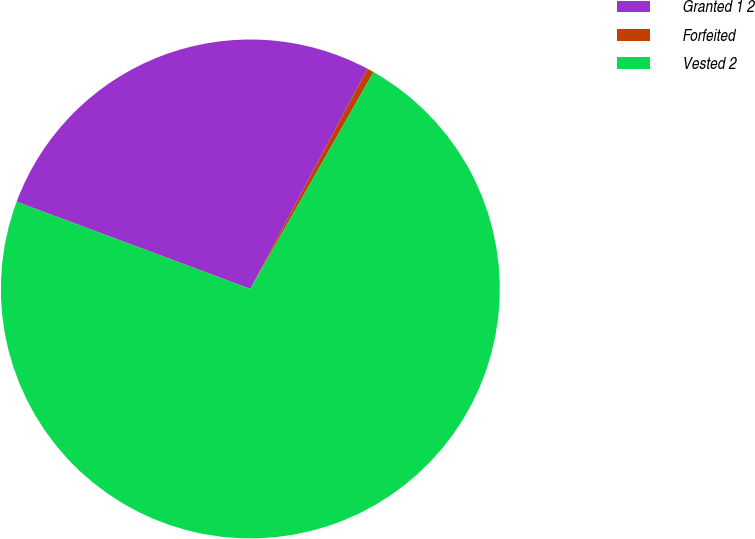<chart> <loc_0><loc_0><loc_500><loc_500><pie_chart><fcel>Granted 1 2<fcel>Forfeited<fcel>Vested 2<nl><fcel>27.1%<fcel>0.44%<fcel>72.46%<nl></chart> 